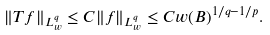Convert formula to latex. <formula><loc_0><loc_0><loc_500><loc_500>\| T f \| _ { L ^ { q } _ { w } } \leq C \| f \| _ { L ^ { q } _ { w } } \leq C w ( B ) ^ { 1 / q - 1 / p } .</formula> 